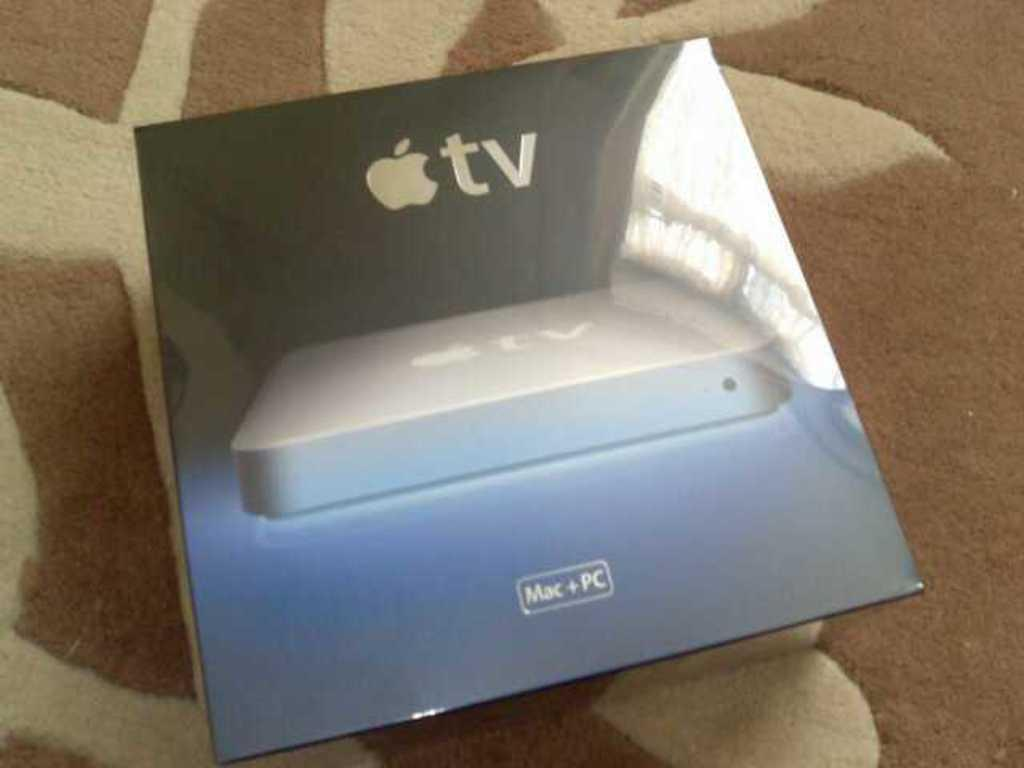Provide a one-sentence caption for the provided image. The box contains an Apple TV device for use with Mac or PC. 